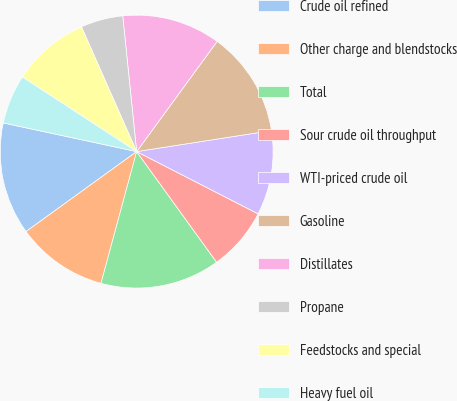Convert chart to OTSL. <chart><loc_0><loc_0><loc_500><loc_500><pie_chart><fcel>Crude oil refined<fcel>Other charge and blendstocks<fcel>Total<fcel>Sour crude oil throughput<fcel>WTI-priced crude oil<fcel>Gasoline<fcel>Distillates<fcel>Propane<fcel>Feedstocks and special<fcel>Heavy fuel oil<nl><fcel>13.33%<fcel>10.83%<fcel>14.17%<fcel>7.5%<fcel>10.0%<fcel>12.5%<fcel>11.67%<fcel>5.0%<fcel>9.17%<fcel>5.83%<nl></chart> 